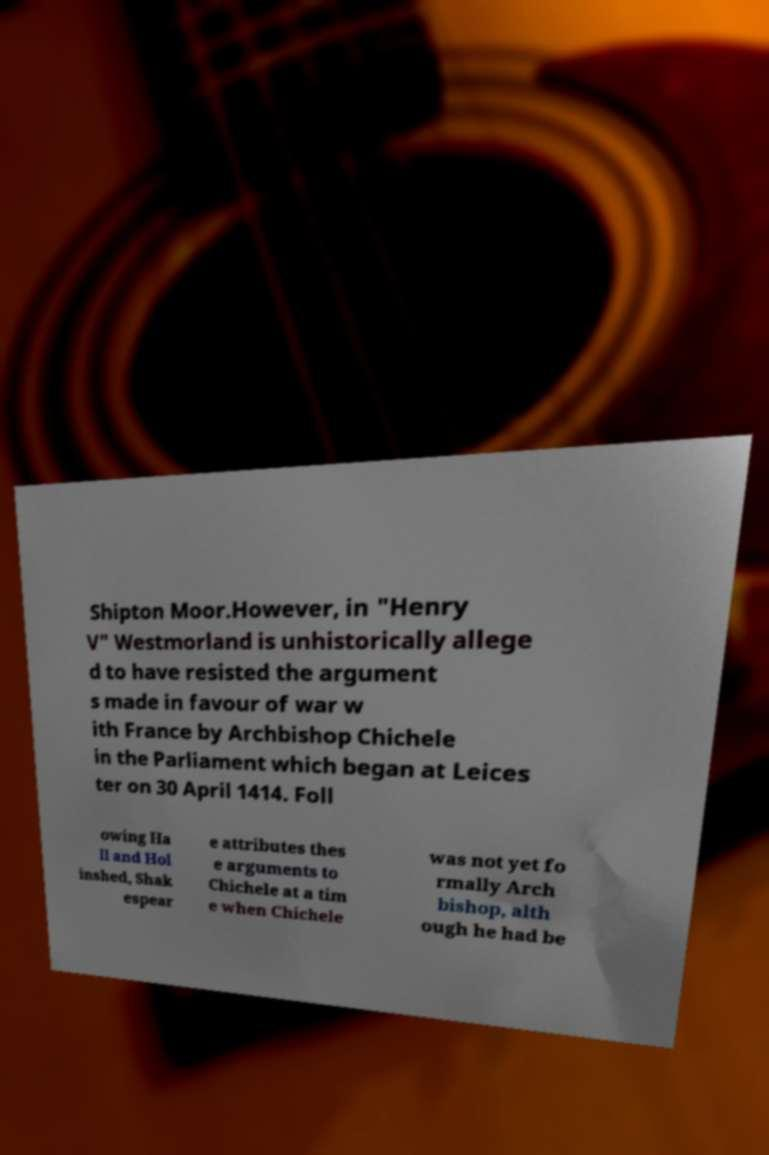Can you read and provide the text displayed in the image?This photo seems to have some interesting text. Can you extract and type it out for me? Shipton Moor.However, in "Henry V" Westmorland is unhistorically allege d to have resisted the argument s made in favour of war w ith France by Archbishop Chichele in the Parliament which began at Leices ter on 30 April 1414. Foll owing Ha ll and Hol inshed, Shak espear e attributes thes e arguments to Chichele at a tim e when Chichele was not yet fo rmally Arch bishop, alth ough he had be 